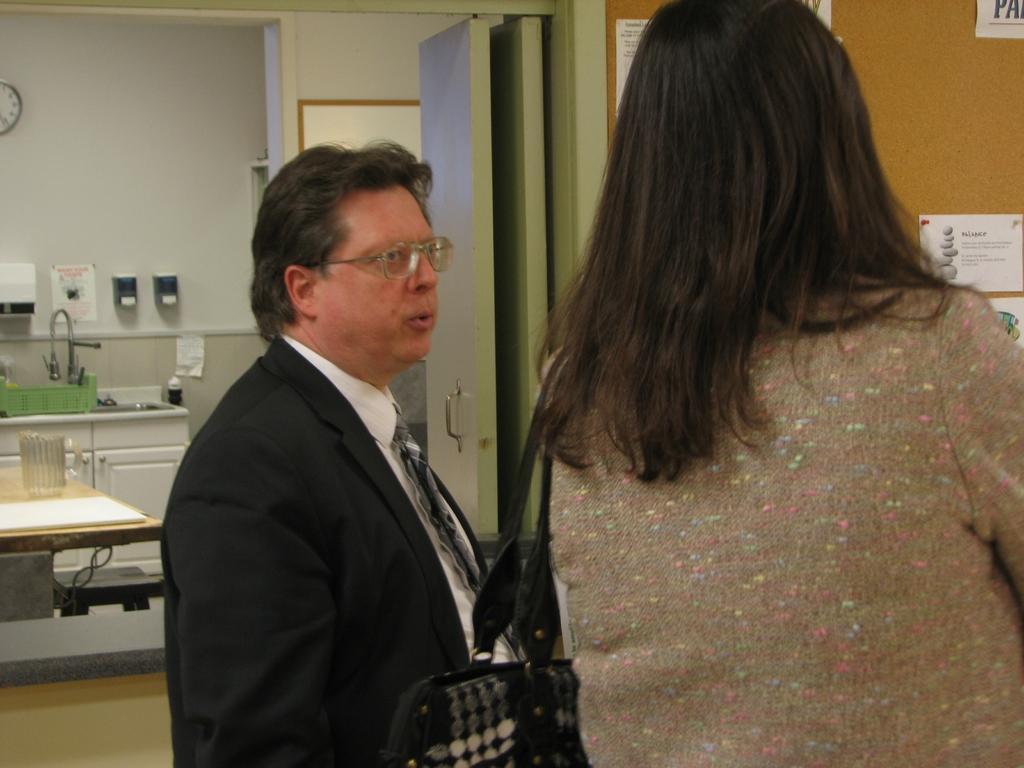In one or two sentences, can you explain what this image depicts? In this image I can see two people standing one person is facing towards the right, another person standing on the right hand side of the image facing towards the back. I can see a table, a wooden cupboard, a watch, a tap and so many other devices on the left hand side. I can see a door and a wall with some labels on the right hand side. 